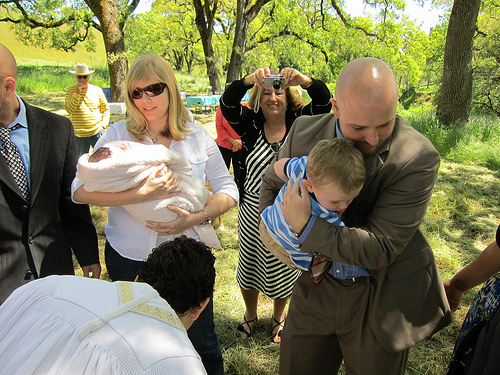<image>
Is the baby on the man? Yes. Looking at the image, I can see the baby is positioned on top of the man, with the man providing support. 